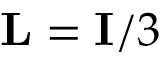Convert formula to latex. <formula><loc_0><loc_0><loc_500><loc_500>{ L } = { I } / 3</formula> 